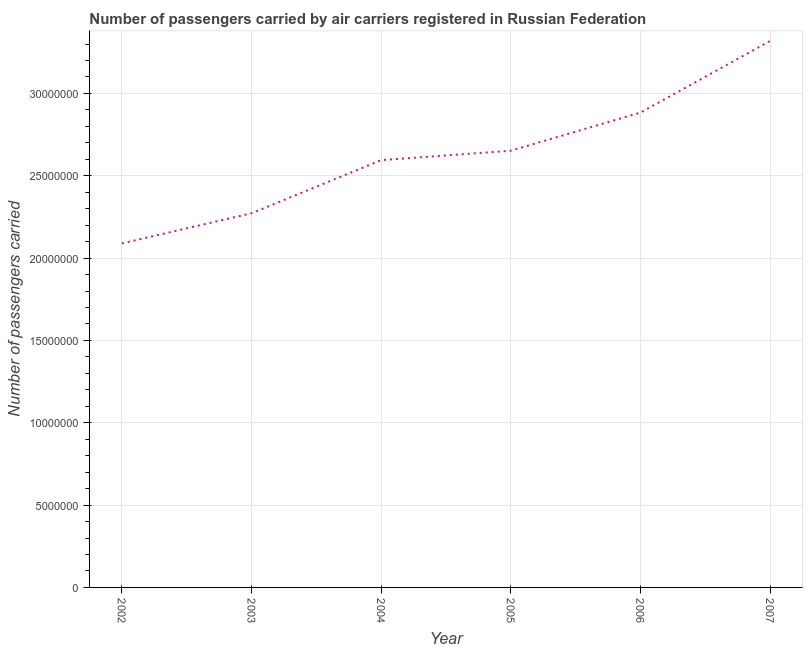What is the number of passengers carried in 2005?
Provide a short and direct response. 2.65e+07. Across all years, what is the maximum number of passengers carried?
Keep it short and to the point. 3.32e+07. Across all years, what is the minimum number of passengers carried?
Provide a short and direct response. 2.09e+07. In which year was the number of passengers carried minimum?
Offer a very short reply. 2002. What is the sum of the number of passengers carried?
Provide a short and direct response. 1.58e+08. What is the difference between the number of passengers carried in 2002 and 2004?
Provide a succinct answer. -5.06e+06. What is the average number of passengers carried per year?
Offer a terse response. 2.64e+07. What is the median number of passengers carried?
Provide a short and direct response. 2.62e+07. What is the ratio of the number of passengers carried in 2002 to that in 2007?
Offer a terse response. 0.63. Is the difference between the number of passengers carried in 2005 and 2006 greater than the difference between any two years?
Your answer should be compact. No. What is the difference between the highest and the second highest number of passengers carried?
Your answer should be compact. 4.35e+06. Is the sum of the number of passengers carried in 2003 and 2004 greater than the maximum number of passengers carried across all years?
Your answer should be compact. Yes. What is the difference between the highest and the lowest number of passengers carried?
Offer a very short reply. 1.23e+07. How many lines are there?
Provide a short and direct response. 1. What is the difference between two consecutive major ticks on the Y-axis?
Keep it short and to the point. 5.00e+06. Does the graph contain grids?
Your response must be concise. Yes. What is the title of the graph?
Your response must be concise. Number of passengers carried by air carriers registered in Russian Federation. What is the label or title of the X-axis?
Your response must be concise. Year. What is the label or title of the Y-axis?
Offer a terse response. Number of passengers carried. What is the Number of passengers carried of 2002?
Keep it short and to the point. 2.09e+07. What is the Number of passengers carried in 2003?
Offer a very short reply. 2.27e+07. What is the Number of passengers carried in 2004?
Provide a succinct answer. 2.59e+07. What is the Number of passengers carried in 2005?
Your answer should be very brief. 2.65e+07. What is the Number of passengers carried of 2006?
Provide a short and direct response. 2.88e+07. What is the Number of passengers carried in 2007?
Ensure brevity in your answer.  3.32e+07. What is the difference between the Number of passengers carried in 2002 and 2003?
Make the answer very short. -1.83e+06. What is the difference between the Number of passengers carried in 2002 and 2004?
Provide a succinct answer. -5.06e+06. What is the difference between the Number of passengers carried in 2002 and 2005?
Give a very brief answer. -5.63e+06. What is the difference between the Number of passengers carried in 2002 and 2006?
Your answer should be compact. -7.94e+06. What is the difference between the Number of passengers carried in 2002 and 2007?
Provide a short and direct response. -1.23e+07. What is the difference between the Number of passengers carried in 2003 and 2004?
Ensure brevity in your answer.  -3.23e+06. What is the difference between the Number of passengers carried in 2003 and 2005?
Your response must be concise. -3.80e+06. What is the difference between the Number of passengers carried in 2003 and 2006?
Offer a very short reply. -6.11e+06. What is the difference between the Number of passengers carried in 2003 and 2007?
Offer a terse response. -1.05e+07. What is the difference between the Number of passengers carried in 2004 and 2005?
Your response must be concise. -5.73e+05. What is the difference between the Number of passengers carried in 2004 and 2006?
Ensure brevity in your answer.  -2.89e+06. What is the difference between the Number of passengers carried in 2004 and 2007?
Make the answer very short. -7.24e+06. What is the difference between the Number of passengers carried in 2005 and 2006?
Keep it short and to the point. -2.31e+06. What is the difference between the Number of passengers carried in 2005 and 2007?
Ensure brevity in your answer.  -6.67e+06. What is the difference between the Number of passengers carried in 2006 and 2007?
Provide a short and direct response. -4.35e+06. What is the ratio of the Number of passengers carried in 2002 to that in 2003?
Provide a short and direct response. 0.92. What is the ratio of the Number of passengers carried in 2002 to that in 2004?
Offer a terse response. 0.81. What is the ratio of the Number of passengers carried in 2002 to that in 2005?
Ensure brevity in your answer.  0.79. What is the ratio of the Number of passengers carried in 2002 to that in 2006?
Give a very brief answer. 0.72. What is the ratio of the Number of passengers carried in 2002 to that in 2007?
Provide a succinct answer. 0.63. What is the ratio of the Number of passengers carried in 2003 to that in 2004?
Give a very brief answer. 0.88. What is the ratio of the Number of passengers carried in 2003 to that in 2005?
Provide a succinct answer. 0.86. What is the ratio of the Number of passengers carried in 2003 to that in 2006?
Make the answer very short. 0.79. What is the ratio of the Number of passengers carried in 2003 to that in 2007?
Ensure brevity in your answer.  0.69. What is the ratio of the Number of passengers carried in 2004 to that in 2005?
Your response must be concise. 0.98. What is the ratio of the Number of passengers carried in 2004 to that in 2006?
Offer a terse response. 0.9. What is the ratio of the Number of passengers carried in 2004 to that in 2007?
Offer a very short reply. 0.78. What is the ratio of the Number of passengers carried in 2005 to that in 2007?
Your response must be concise. 0.8. What is the ratio of the Number of passengers carried in 2006 to that in 2007?
Offer a terse response. 0.87. 